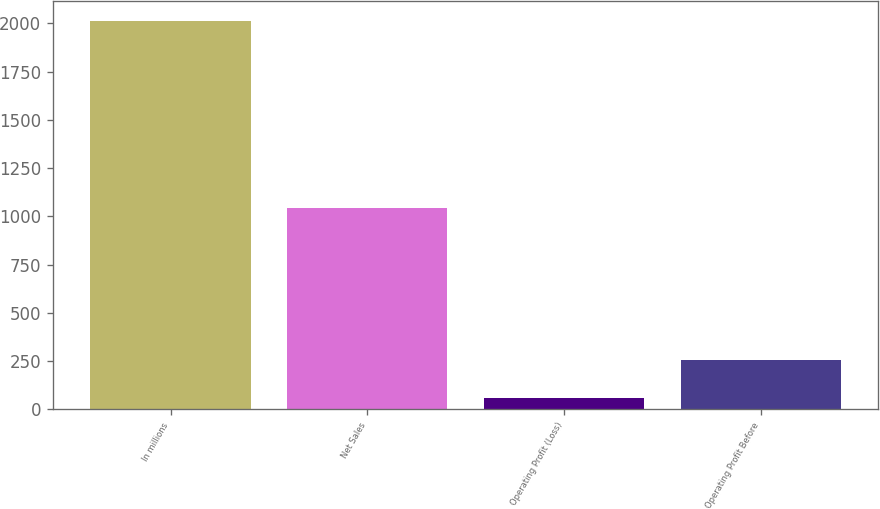Convert chart. <chart><loc_0><loc_0><loc_500><loc_500><bar_chart><fcel>In millions<fcel>Net Sales<fcel>Operating Profit (Loss)<fcel>Operating Profit Before<nl><fcel>2014<fcel>1046<fcel>61<fcel>256.3<nl></chart> 